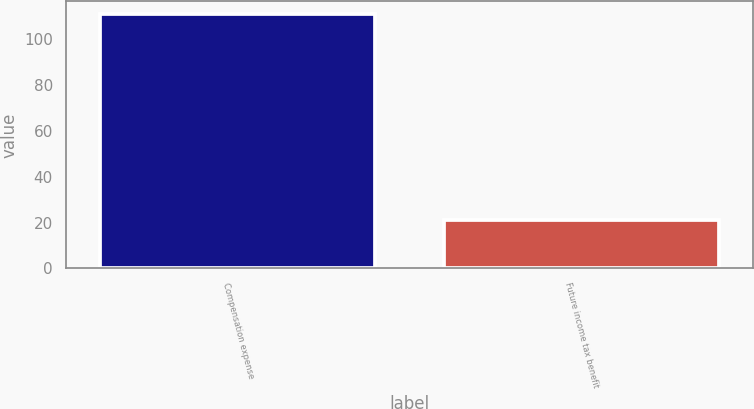Convert chart to OTSL. <chart><loc_0><loc_0><loc_500><loc_500><bar_chart><fcel>Compensation expense<fcel>Future income tax benefit<nl><fcel>111<fcel>21<nl></chart> 